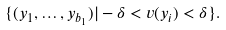<formula> <loc_0><loc_0><loc_500><loc_500>\{ ( y _ { 1 } , \dots , y _ { b _ { 1 } } ) | - \delta < v ( y _ { i } ) < \delta \} .</formula> 